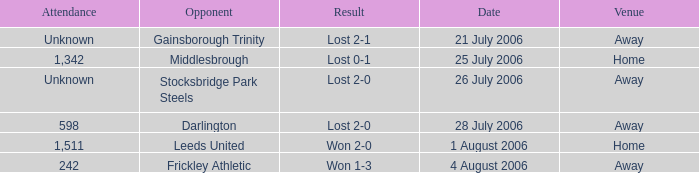Which opponent has unknown attendance, and lost 2-0? Stocksbridge Park Steels. 